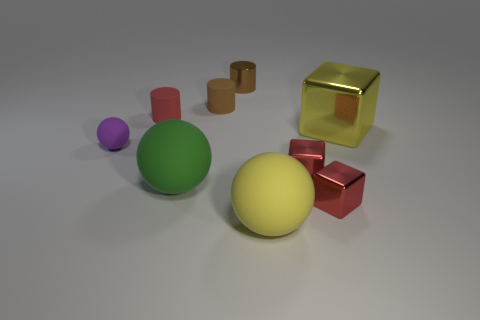Add 1 cylinders. How many objects exist? 10 Subtract all blocks. How many objects are left? 6 Add 8 big gray rubber cubes. How many big gray rubber cubes exist? 8 Subtract 0 green cylinders. How many objects are left? 9 Subtract all tiny red matte things. Subtract all big yellow matte objects. How many objects are left? 7 Add 5 purple matte balls. How many purple matte balls are left? 6 